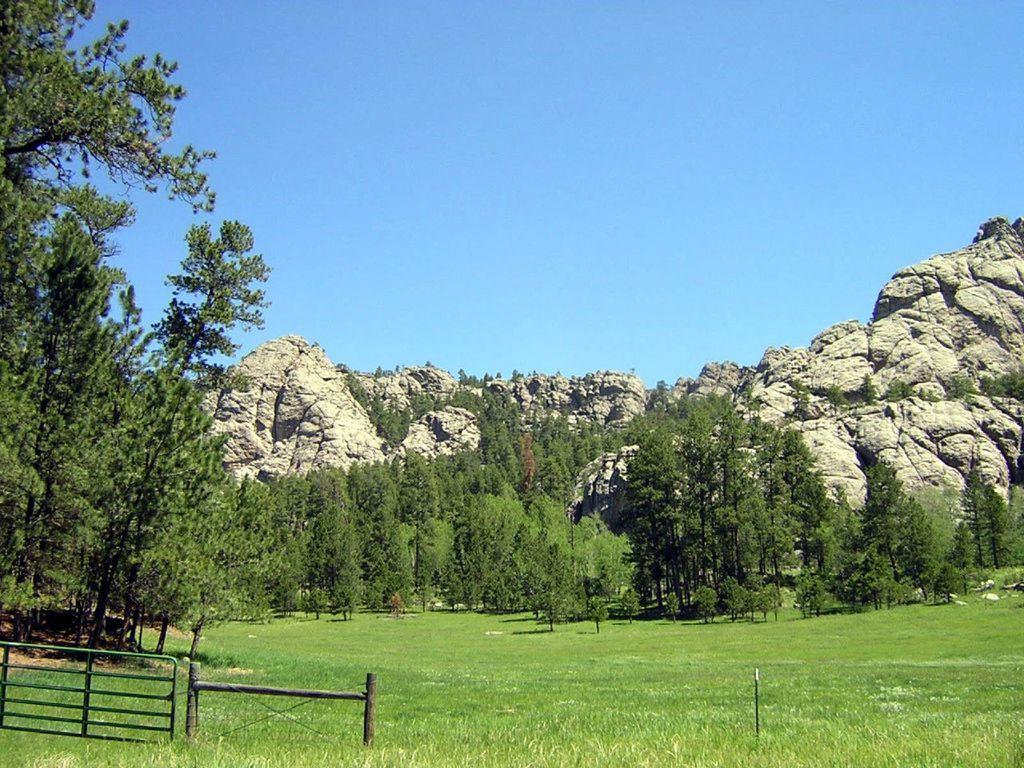What type of natural formation can be seen in the background of the image? There are mountains in the background of the image. What type of vegetation is present in the image? There are trees in the image. What type of ground cover is at the bottom of the image? There is grass at the bottom of the image. What type of barrier is visible in the image? There is a fencing in the image. What type of pencil can be seen in the image? There is no pencil present in the image. How many umbrellas are visible in the image? There are no umbrellas visible in the image. 